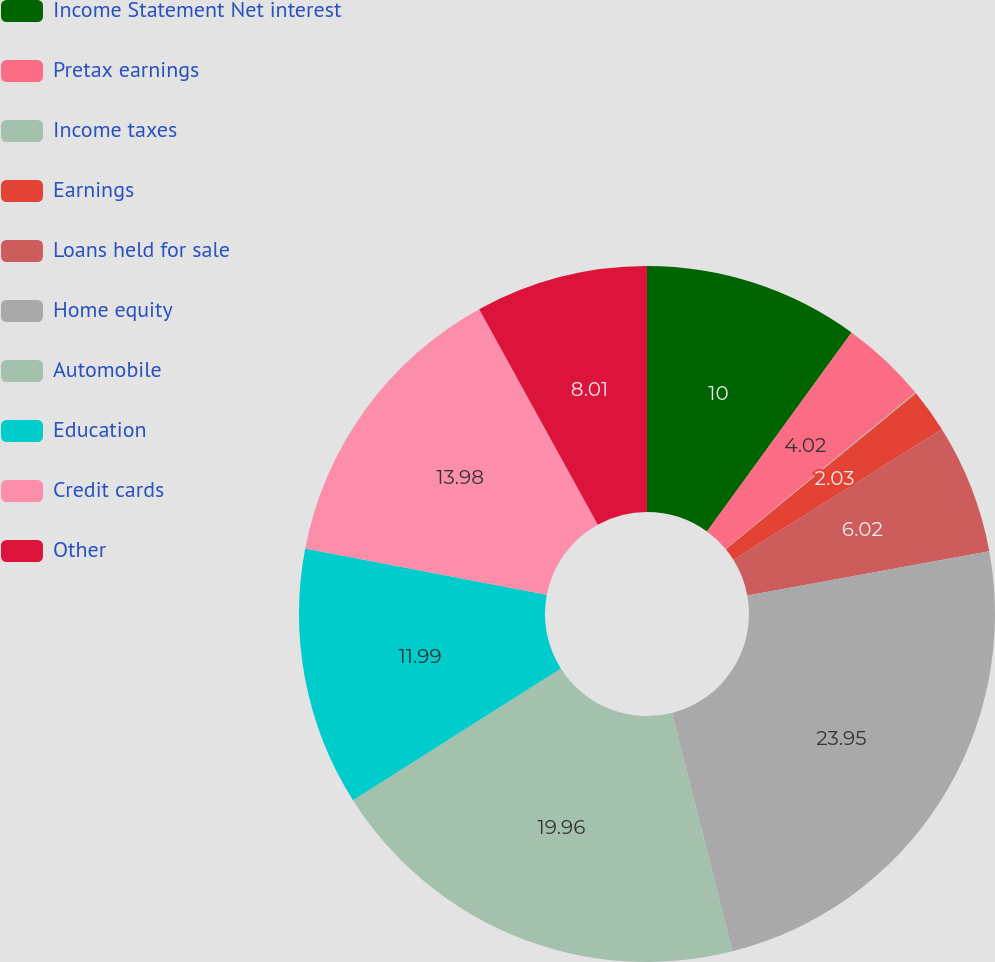Convert chart to OTSL. <chart><loc_0><loc_0><loc_500><loc_500><pie_chart><fcel>Income Statement Net interest<fcel>Pretax earnings<fcel>Income taxes<fcel>Earnings<fcel>Loans held for sale<fcel>Home equity<fcel>Automobile<fcel>Education<fcel>Credit cards<fcel>Other<nl><fcel>10.0%<fcel>4.02%<fcel>0.04%<fcel>2.03%<fcel>6.02%<fcel>23.94%<fcel>19.96%<fcel>11.99%<fcel>13.98%<fcel>8.01%<nl></chart> 